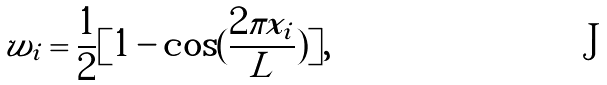Convert formula to latex. <formula><loc_0><loc_0><loc_500><loc_500>w _ { i } = \frac { 1 } { 2 } [ 1 - \cos ( \frac { 2 \pi x _ { i } } { L } ) ] ,</formula> 